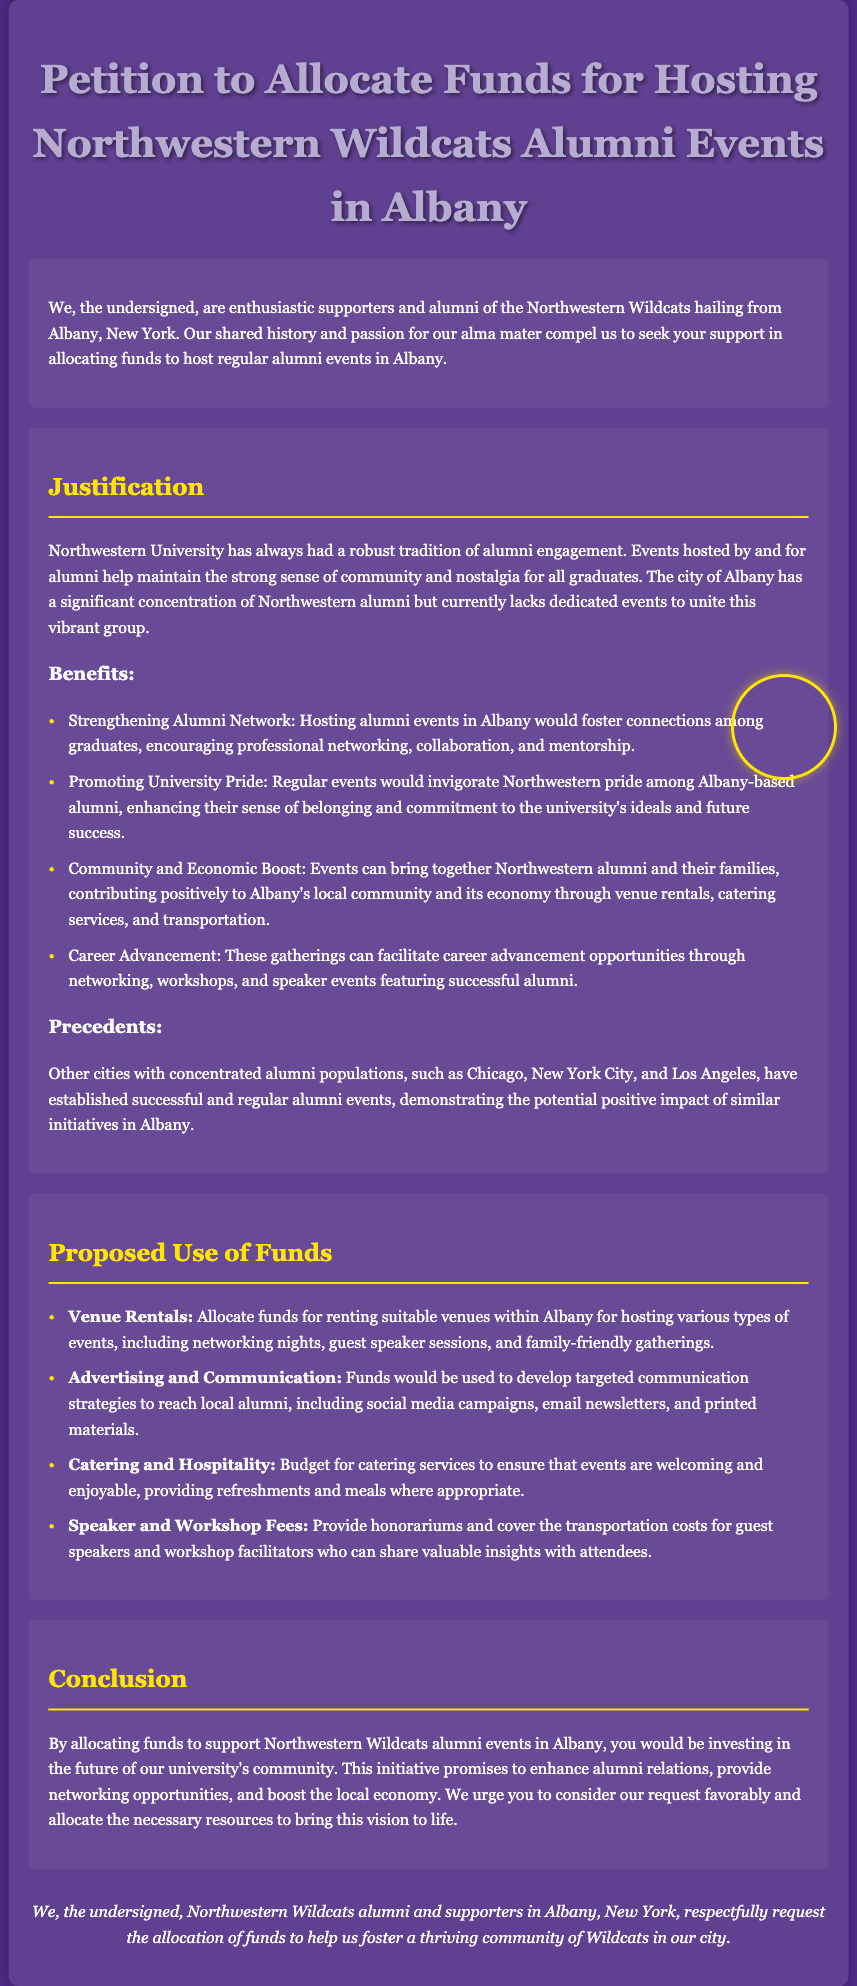What is the title of the petition? The title of the petition is mentioned prominently at the top of the document.
Answer: Petition to Allocate Funds for Hosting Northwestern Wildcats Alumni Events in Albany Who are the petitioners? The petitioners are defined as a group of people in the introduction section of the document.
Answer: enthusiastic supporters and alumni of the Northwestern Wildcats What city is the focus of this petition? The city that is referenced throughout the document is stated clearly in the introduction.
Answer: Albany What are the proposed uses of funds for catering? The section detailing proposed uses includes specific funding allocations.
Answer: Catering and Hospitality List one benefit of hosting alumni events according to the document. The document outlines multiple benefits of hosting events, indicating the main points.
Answer: Strengthening Alumni Network How many types of alumni events are proposed? The document mentions multiple types of events under the proposed use of funds.
Answer: Various types Mention one city that has established successful alumni events. Precedents are given in the document discussing other cities with successful events.
Answer: Chicago What are funds intended to cover for guest speakers? The document specifies what will be provided for the speakers, which is a important detail in the budget allocation.
Answer: Speaker and Workshop Fees What color is the background of the document? The document uses a specific color scheme that is prominent throughout.
Answer: #4E2A84 How are alumni to be reached according to the proposed use of funds? The document lists methods for communication that will be developed to connect with alumni.
Answer: Targeted communication strategies 